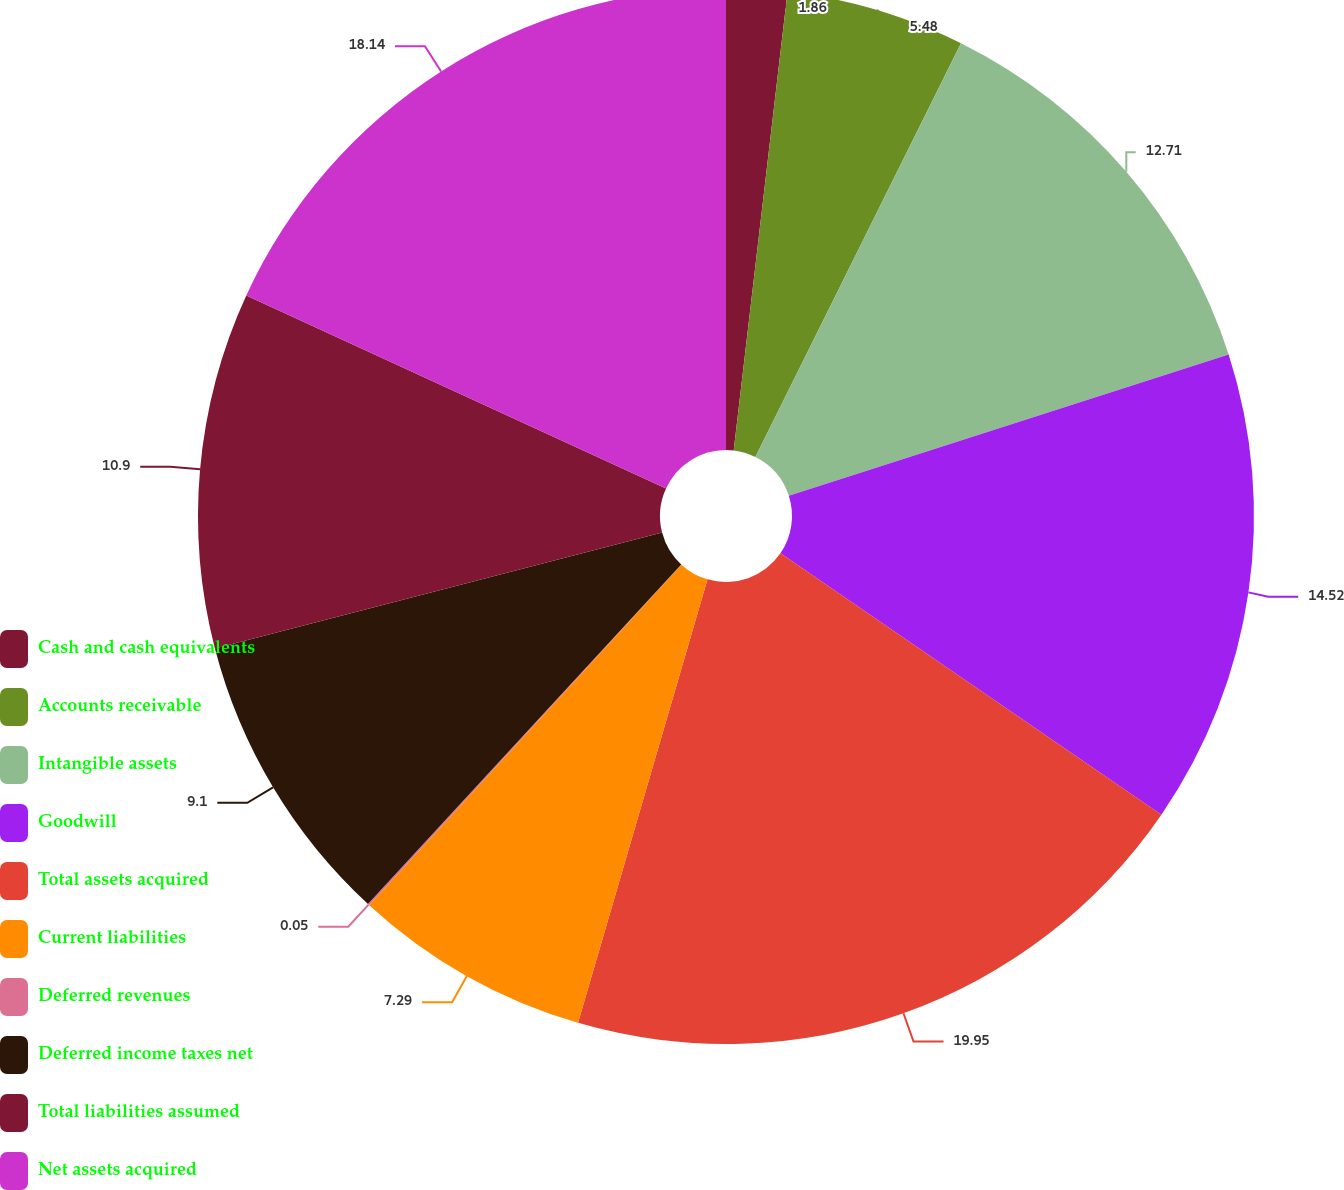Convert chart to OTSL. <chart><loc_0><loc_0><loc_500><loc_500><pie_chart><fcel>Cash and cash equivalents<fcel>Accounts receivable<fcel>Intangible assets<fcel>Goodwill<fcel>Total assets acquired<fcel>Current liabilities<fcel>Deferred revenues<fcel>Deferred income taxes net<fcel>Total liabilities assumed<fcel>Net assets acquired<nl><fcel>1.86%<fcel>5.48%<fcel>12.71%<fcel>14.52%<fcel>19.95%<fcel>7.29%<fcel>0.05%<fcel>9.1%<fcel>10.9%<fcel>18.14%<nl></chart> 